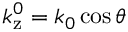<formula> <loc_0><loc_0><loc_500><loc_500>k _ { z } ^ { 0 } = k _ { 0 } \cos \theta</formula> 